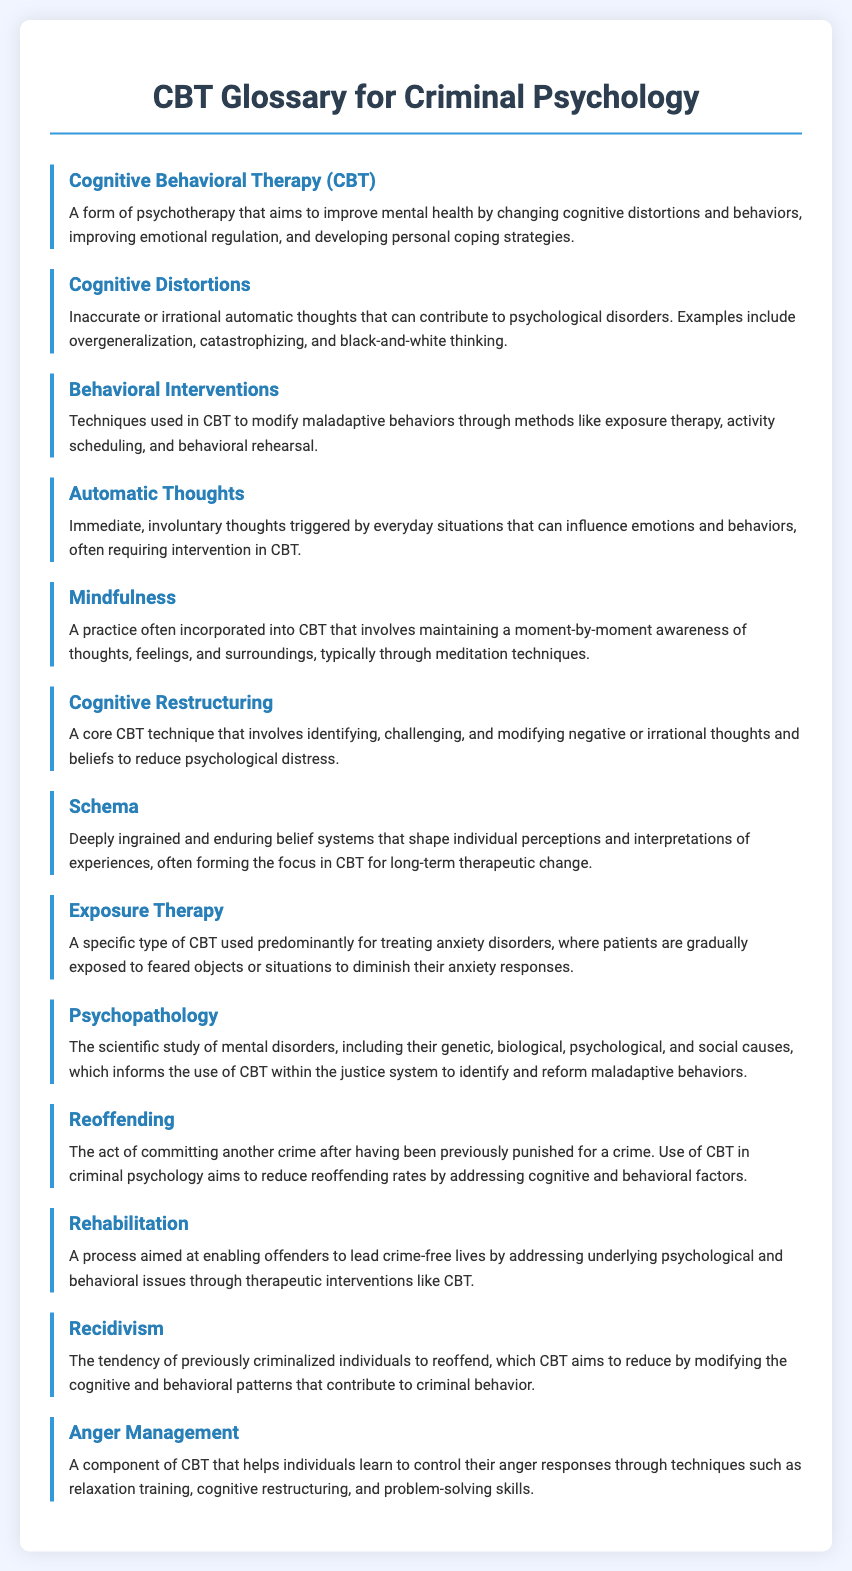What is the title of the document? The title of the document is stated in the `<title>` tag in the HTML header.
Answer: CBT Glossary for Criminal Psychology How many glossary items are included? The glossary items are listed in the document, from the first item to the last.
Answer: 14 What technique does CBT use to identify and challenge negative thoughts? The technique mentioned for this purpose is defined in one of the glossary items.
Answer: Cognitive Restructuring Which term describes inaccurate or irrational automatic thoughts? This term is specifically cited within the glossary for understanding cognitive processes.
Answer: Cognitive Distortions What therapy is predominantly used for treating anxiety disorders? This therapy is specifically identified in the document for addressing anxiety.
Answer: Exposure Therapy What behavioral strategy helps control anger responses? The document describes this strategy as a component of CBT aimed at emotional regulation.
Answer: Anger Management What psychological concept refers to the study of mental disorders? This concept is addressed within the context of the glossary items and informs the use of CBT.
Answer: Psychopathology Which term refers to committing another crime after prior punishment? This term is defined in the document to describe a specific behavioral outcome.
Answer: Reoffending What is the goal of rehabilitation in the context of criminal psychology? This goal is explained within the glossary and connects to therapeutic interventions like CBT.
Answer: Enable offenders to lead crime-free lives 